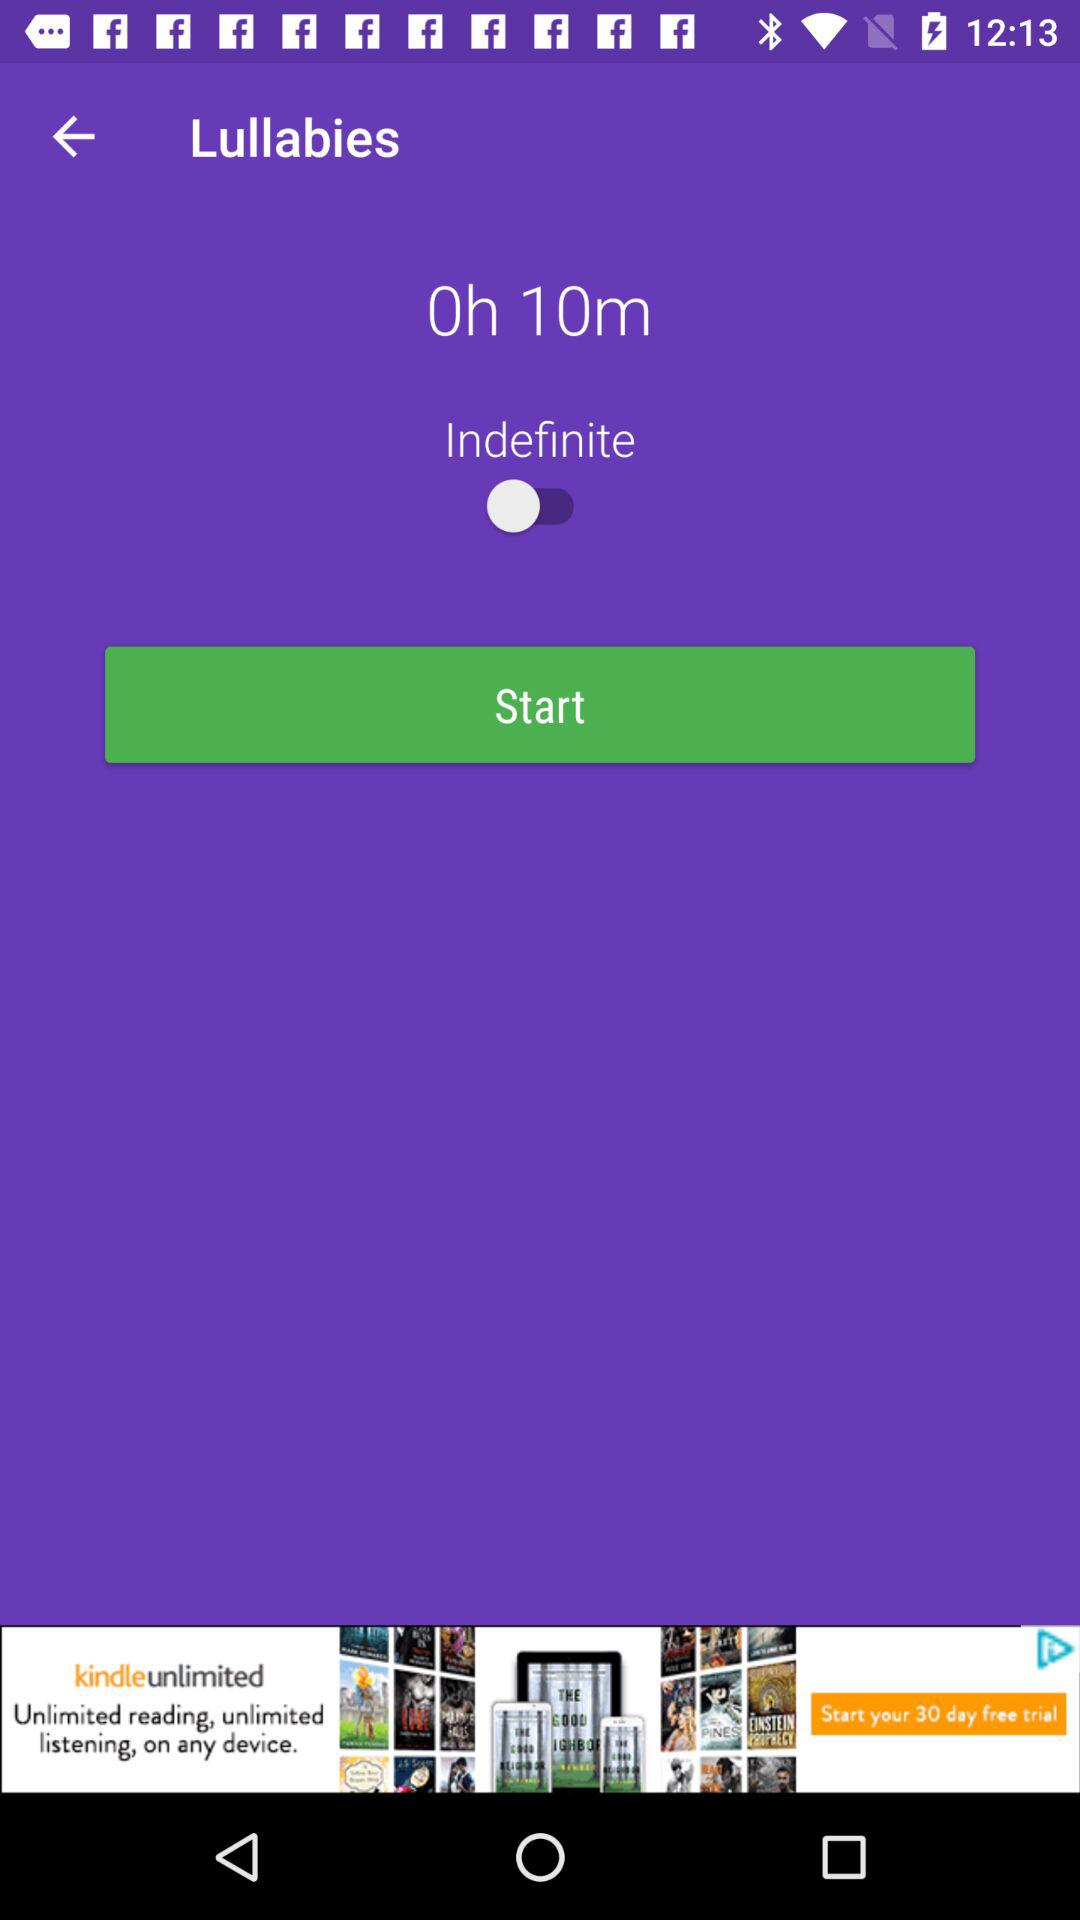What is the status of the "Indefinite"? The status is "off". 